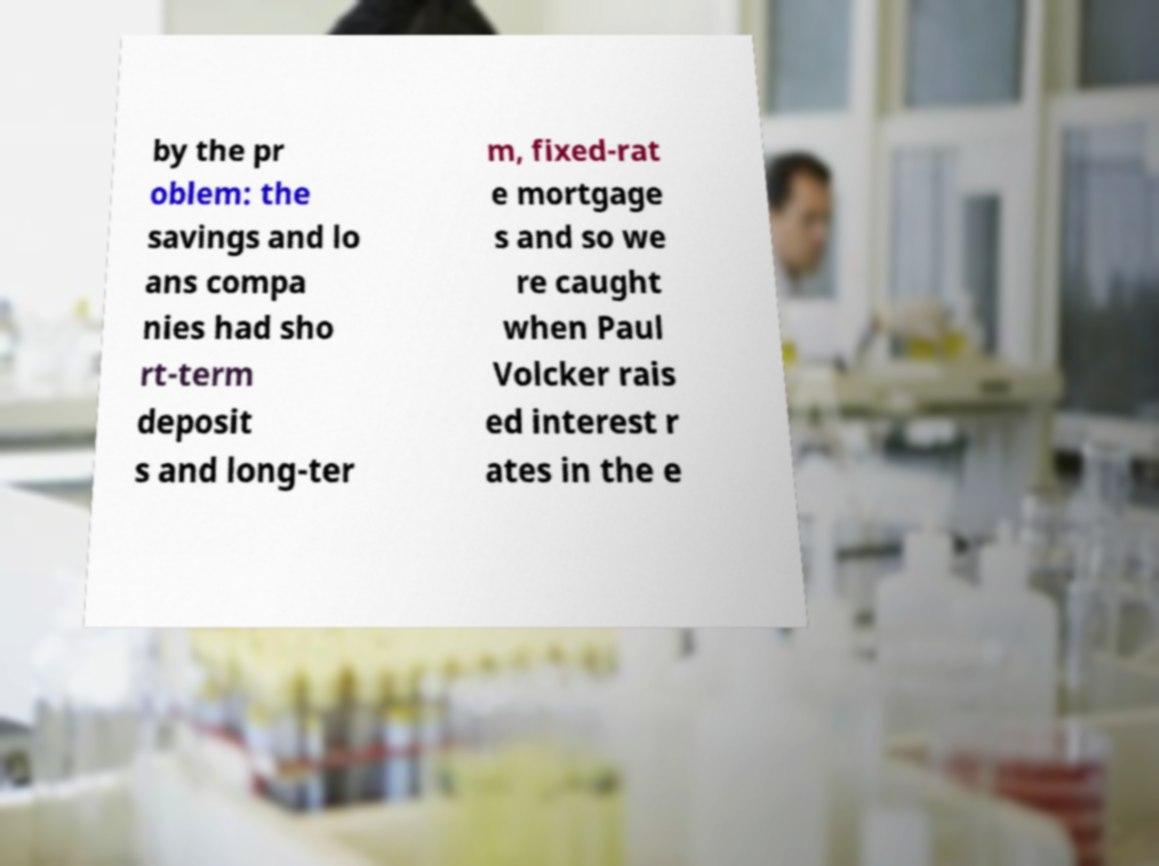What messages or text are displayed in this image? I need them in a readable, typed format. by the pr oblem: the savings and lo ans compa nies had sho rt-term deposit s and long-ter m, fixed-rat e mortgage s and so we re caught when Paul Volcker rais ed interest r ates in the e 